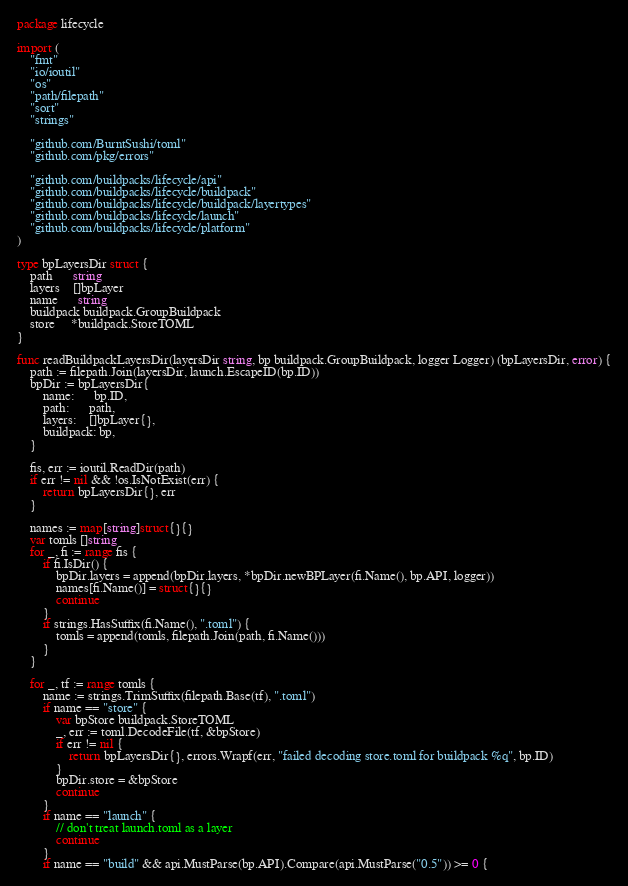<code> <loc_0><loc_0><loc_500><loc_500><_Go_>package lifecycle

import (
	"fmt"
	"io/ioutil"
	"os"
	"path/filepath"
	"sort"
	"strings"

	"github.com/BurntSushi/toml"
	"github.com/pkg/errors"

	"github.com/buildpacks/lifecycle/api"
	"github.com/buildpacks/lifecycle/buildpack"
	"github.com/buildpacks/lifecycle/buildpack/layertypes"
	"github.com/buildpacks/lifecycle/launch"
	"github.com/buildpacks/lifecycle/platform"
)

type bpLayersDir struct {
	path      string
	layers    []bpLayer
	name      string
	buildpack buildpack.GroupBuildpack
	store     *buildpack.StoreTOML
}

func readBuildpackLayersDir(layersDir string, bp buildpack.GroupBuildpack, logger Logger) (bpLayersDir, error) {
	path := filepath.Join(layersDir, launch.EscapeID(bp.ID))
	bpDir := bpLayersDir{
		name:      bp.ID,
		path:      path,
		layers:    []bpLayer{},
		buildpack: bp,
	}

	fis, err := ioutil.ReadDir(path)
	if err != nil && !os.IsNotExist(err) {
		return bpLayersDir{}, err
	}

	names := map[string]struct{}{}
	var tomls []string
	for _, fi := range fis {
		if fi.IsDir() {
			bpDir.layers = append(bpDir.layers, *bpDir.newBPLayer(fi.Name(), bp.API, logger))
			names[fi.Name()] = struct{}{}
			continue
		}
		if strings.HasSuffix(fi.Name(), ".toml") {
			tomls = append(tomls, filepath.Join(path, fi.Name()))
		}
	}

	for _, tf := range tomls {
		name := strings.TrimSuffix(filepath.Base(tf), ".toml")
		if name == "store" {
			var bpStore buildpack.StoreTOML
			_, err := toml.DecodeFile(tf, &bpStore)
			if err != nil {
				return bpLayersDir{}, errors.Wrapf(err, "failed decoding store.toml for buildpack %q", bp.ID)
			}
			bpDir.store = &bpStore
			continue
		}
		if name == "launch" {
			// don't treat launch.toml as a layer
			continue
		}
		if name == "build" && api.MustParse(bp.API).Compare(api.MustParse("0.5")) >= 0 {</code> 